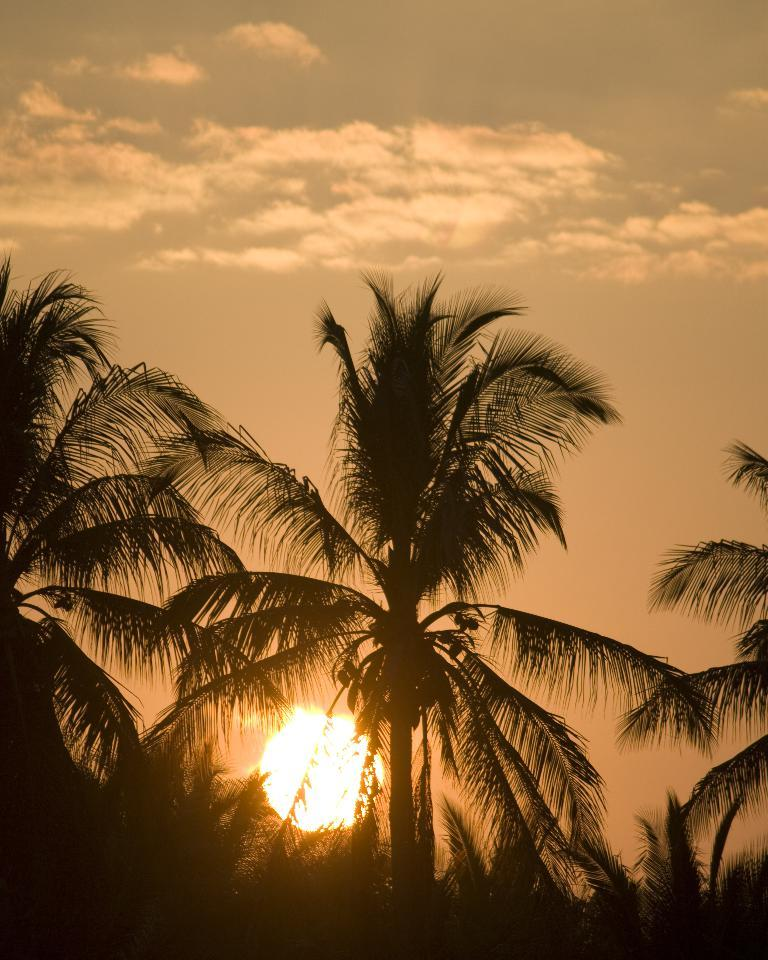What type of vegetation can be seen in the image? There are trees in the image. What is the condition of the sun in the sky? The sun is bright in the sky. What else can be seen in the sky besides the sun? There are clouds visible in the sky. What type of wire can be seen connecting the trees in the image? There is no wire connecting the trees in the image; only the trees, sun, and clouds are present. 